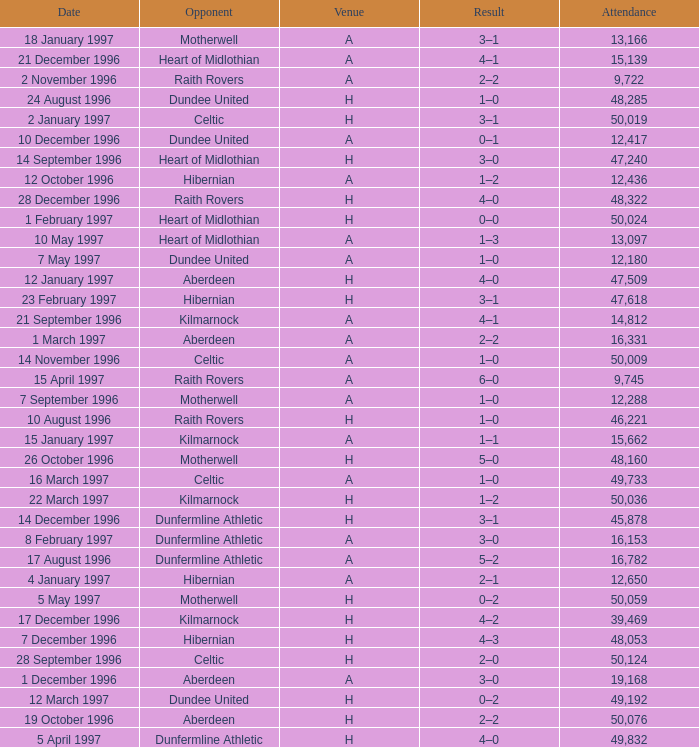When did venue A have an attendance larger than 48,053, and a result of 1–0? 14 November 1996, 16 March 1997. 